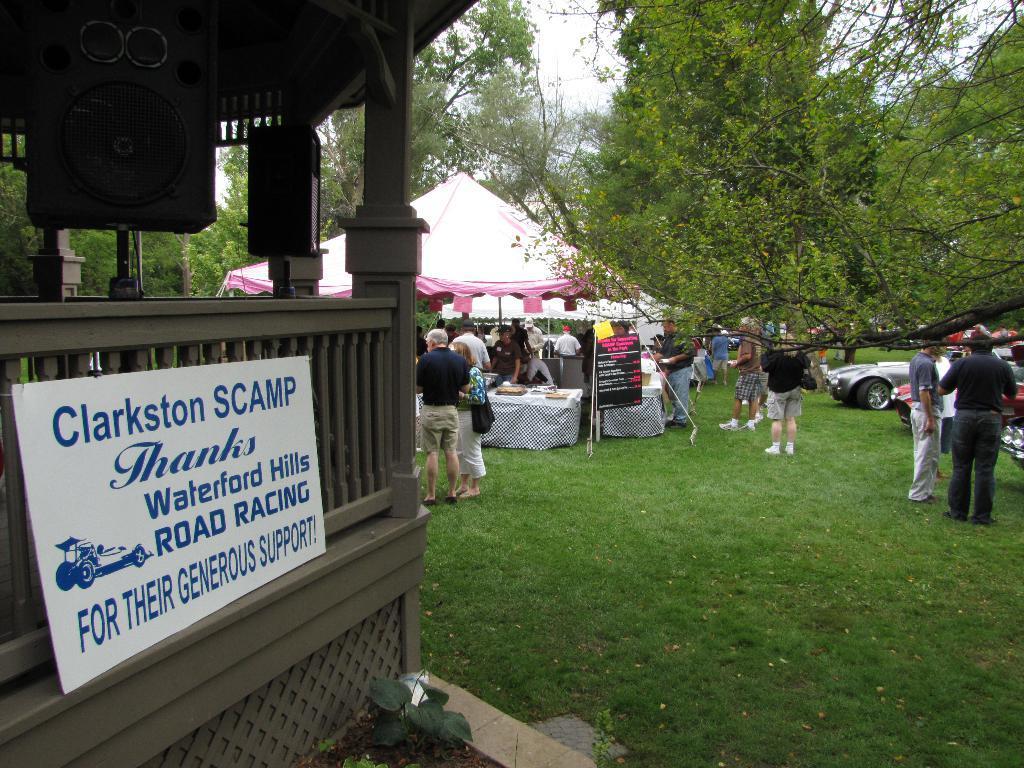Describe this image in one or two sentences. In this image we can see the people standing on the grass. We can also see the tent for shelter. We can see the tables, banner, trees and also the sky. On the left, we can see a sound box, a text board and also the roof for shelter. We can see the plants and also the soil and dried leaves. 